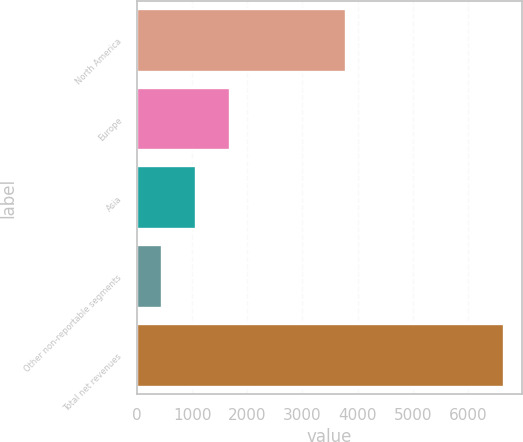<chart> <loc_0><loc_0><loc_500><loc_500><bar_chart><fcel>North America<fcel>Europe<fcel>Asia<fcel>Other non-reportable segments<fcel>Total net revenues<nl><fcel>3783<fcel>1685.68<fcel>1064.79<fcel>443.9<fcel>6652.8<nl></chart> 